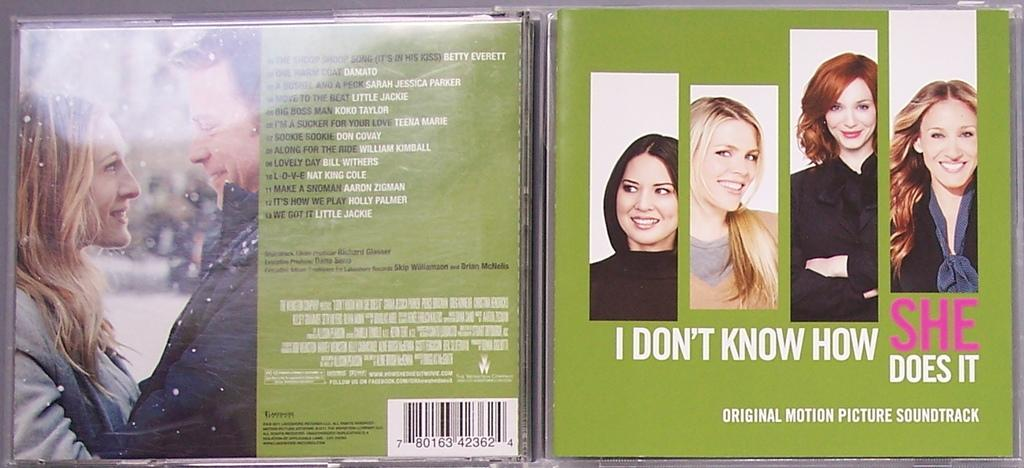What is present on the poster in the image? The poster contains text and images. Can you describe the content of the poster? The poster contains text and images, but the specific content cannot be determined from the provided facts. Are there any bears visible on the poster in the image? There is no mention of bears in the provided facts, so it cannot be determined if they are present on the poster. 